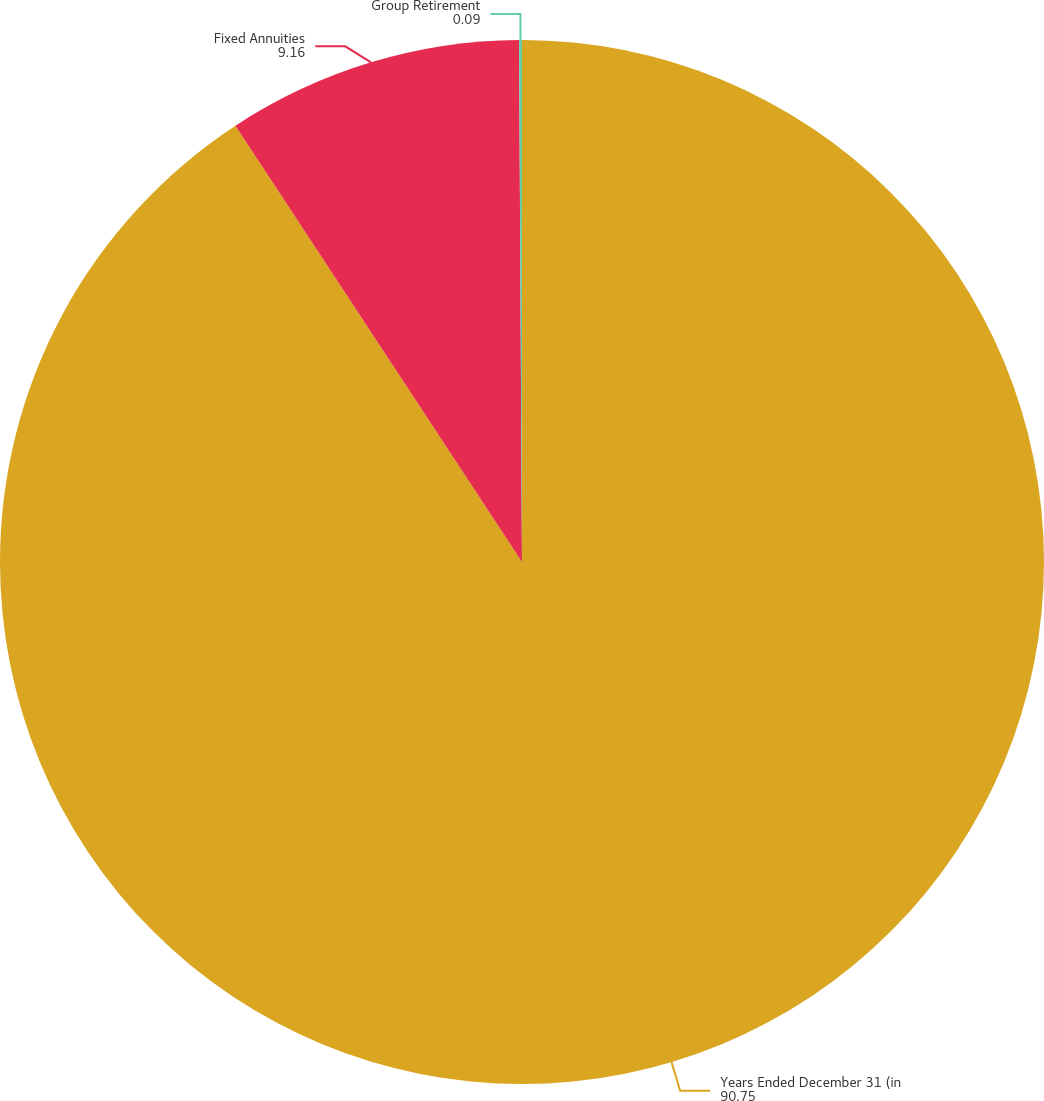<chart> <loc_0><loc_0><loc_500><loc_500><pie_chart><fcel>Years Ended December 31 (in<fcel>Fixed Annuities<fcel>Group Retirement<nl><fcel>90.75%<fcel>9.16%<fcel>0.09%<nl></chart> 